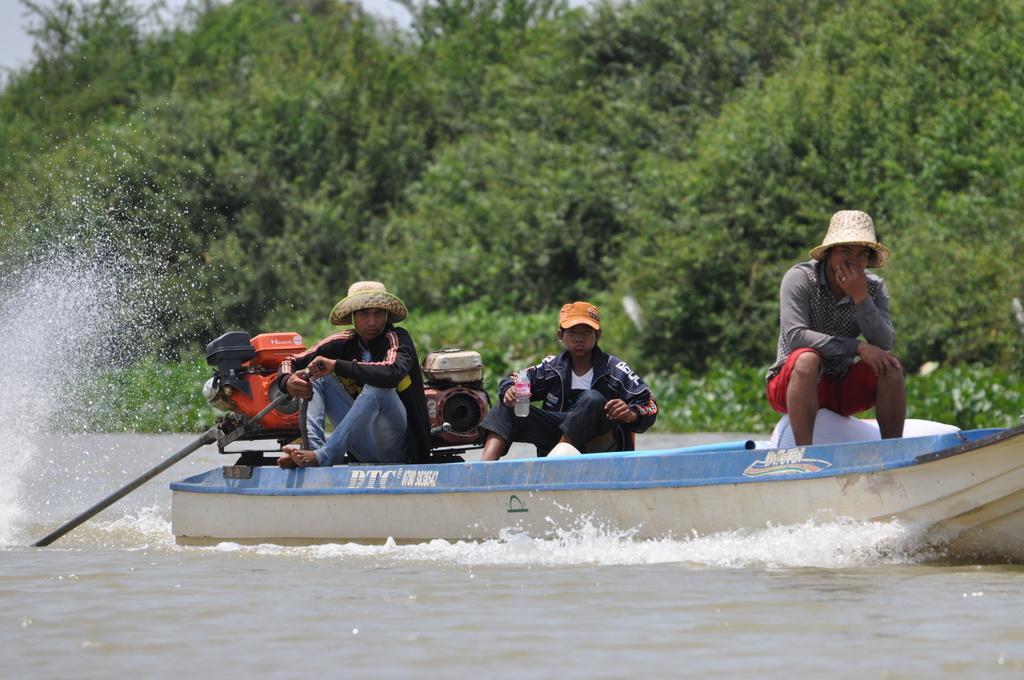Could you give a brief overview of what you see in this image? In this image there are people sitting on the boat. Beside them there are a few objects. At the bottom of the image there is water. In the background of the image there are trees and sky. 